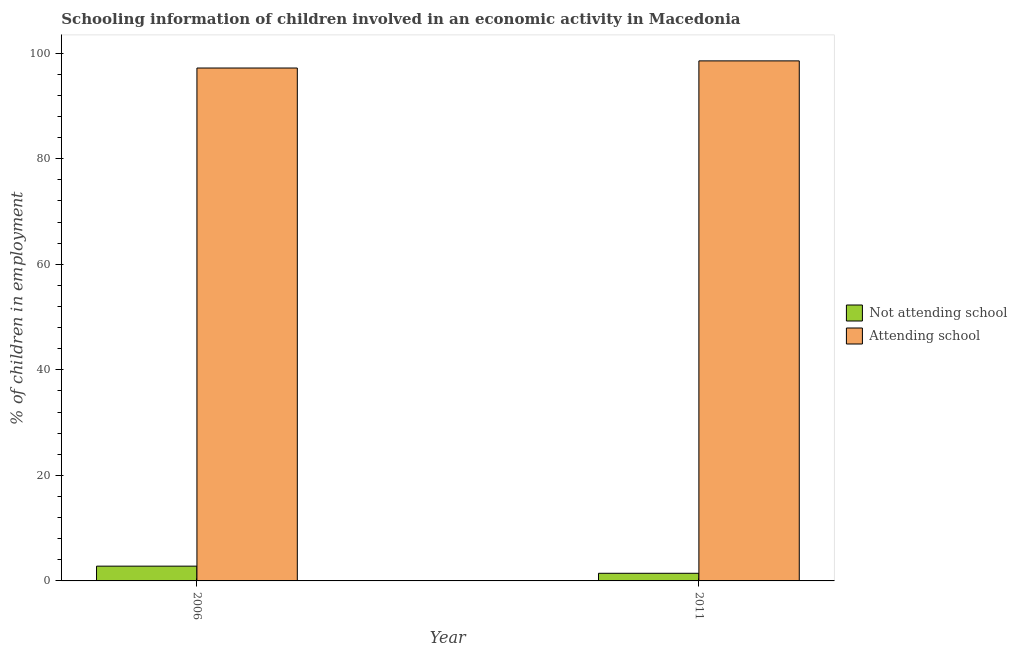How many different coloured bars are there?
Give a very brief answer. 2. Are the number of bars on each tick of the X-axis equal?
Offer a very short reply. Yes. How many bars are there on the 1st tick from the left?
Give a very brief answer. 2. What is the label of the 2nd group of bars from the left?
Ensure brevity in your answer.  2011. What is the percentage of employed children who are not attending school in 2006?
Your response must be concise. 2.8. Across all years, what is the minimum percentage of employed children who are not attending school?
Your answer should be compact. 1.45. In which year was the percentage of employed children who are attending school minimum?
Provide a short and direct response. 2006. What is the total percentage of employed children who are attending school in the graph?
Your answer should be very brief. 195.75. What is the difference between the percentage of employed children who are not attending school in 2006 and that in 2011?
Provide a short and direct response. 1.35. What is the difference between the percentage of employed children who are not attending school in 2011 and the percentage of employed children who are attending school in 2006?
Offer a terse response. -1.35. What is the average percentage of employed children who are not attending school per year?
Give a very brief answer. 2.12. In the year 2011, what is the difference between the percentage of employed children who are attending school and percentage of employed children who are not attending school?
Your answer should be very brief. 0. In how many years, is the percentage of employed children who are not attending school greater than 72 %?
Your answer should be very brief. 0. What is the ratio of the percentage of employed children who are not attending school in 2006 to that in 2011?
Your answer should be very brief. 1.94. Is the percentage of employed children who are attending school in 2006 less than that in 2011?
Offer a terse response. Yes. What does the 1st bar from the left in 2011 represents?
Provide a succinct answer. Not attending school. What does the 2nd bar from the right in 2011 represents?
Keep it short and to the point. Not attending school. Are all the bars in the graph horizontal?
Your response must be concise. No. Does the graph contain any zero values?
Provide a short and direct response. No. What is the title of the graph?
Offer a very short reply. Schooling information of children involved in an economic activity in Macedonia. Does "Services" appear as one of the legend labels in the graph?
Offer a terse response. No. What is the label or title of the X-axis?
Your answer should be compact. Year. What is the label or title of the Y-axis?
Give a very brief answer. % of children in employment. What is the % of children in employment of Attending school in 2006?
Keep it short and to the point. 97.2. What is the % of children in employment in Not attending school in 2011?
Keep it short and to the point. 1.45. What is the % of children in employment of Attending school in 2011?
Offer a terse response. 98.55. Across all years, what is the maximum % of children in employment in Not attending school?
Keep it short and to the point. 2.8. Across all years, what is the maximum % of children in employment in Attending school?
Provide a succinct answer. 98.55. Across all years, what is the minimum % of children in employment in Not attending school?
Offer a very short reply. 1.45. Across all years, what is the minimum % of children in employment in Attending school?
Make the answer very short. 97.2. What is the total % of children in employment of Not attending school in the graph?
Provide a succinct answer. 4.25. What is the total % of children in employment in Attending school in the graph?
Make the answer very short. 195.75. What is the difference between the % of children in employment in Not attending school in 2006 and that in 2011?
Your response must be concise. 1.35. What is the difference between the % of children in employment of Attending school in 2006 and that in 2011?
Your answer should be very brief. -1.35. What is the difference between the % of children in employment of Not attending school in 2006 and the % of children in employment of Attending school in 2011?
Keep it short and to the point. -95.75. What is the average % of children in employment of Not attending school per year?
Your answer should be very brief. 2.12. What is the average % of children in employment of Attending school per year?
Give a very brief answer. 97.88. In the year 2006, what is the difference between the % of children in employment in Not attending school and % of children in employment in Attending school?
Provide a short and direct response. -94.4. In the year 2011, what is the difference between the % of children in employment in Not attending school and % of children in employment in Attending school?
Your response must be concise. -97.11. What is the ratio of the % of children in employment of Not attending school in 2006 to that in 2011?
Offer a terse response. 1.94. What is the ratio of the % of children in employment in Attending school in 2006 to that in 2011?
Offer a terse response. 0.99. What is the difference between the highest and the second highest % of children in employment of Not attending school?
Your answer should be compact. 1.35. What is the difference between the highest and the second highest % of children in employment in Attending school?
Your response must be concise. 1.35. What is the difference between the highest and the lowest % of children in employment in Not attending school?
Provide a succinct answer. 1.35. What is the difference between the highest and the lowest % of children in employment of Attending school?
Your answer should be very brief. 1.35. 